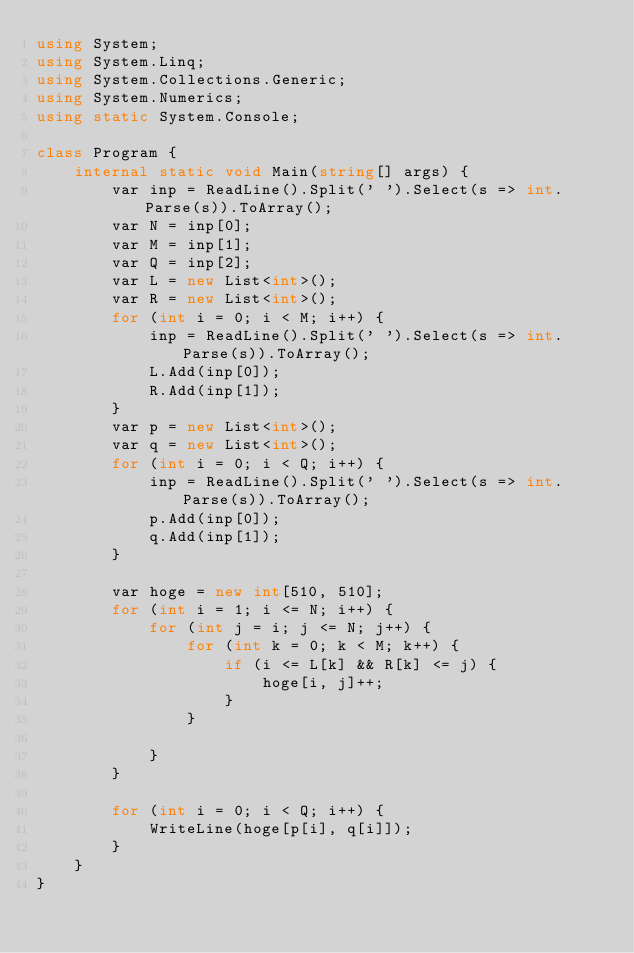Convert code to text. <code><loc_0><loc_0><loc_500><loc_500><_C#_>using System;
using System.Linq;
using System.Collections.Generic;
using System.Numerics;
using static System.Console;

class Program {
    internal static void Main(string[] args) {
        var inp = ReadLine().Split(' ').Select(s => int.Parse(s)).ToArray();
        var N = inp[0];
        var M = inp[1];
        var Q = inp[2];
        var L = new List<int>();
        var R = new List<int>();
        for (int i = 0; i < M; i++) {
            inp = ReadLine().Split(' ').Select(s => int.Parse(s)).ToArray();
            L.Add(inp[0]);
            R.Add(inp[1]);
        }
        var p = new List<int>();
        var q = new List<int>();
        for (int i = 0; i < Q; i++) {
            inp = ReadLine().Split(' ').Select(s => int.Parse(s)).ToArray();
            p.Add(inp[0]);
            q.Add(inp[1]);
        }

        var hoge = new int[510, 510];
        for (int i = 1; i <= N; i++) {
            for (int j = i; j <= N; j++) {
                for (int k = 0; k < M; k++) {
                    if (i <= L[k] && R[k] <= j) {
                        hoge[i, j]++;
                    }
                }

            }
        }

        for (int i = 0; i < Q; i++) {
            WriteLine(hoge[p[i], q[i]]);
        }
    }
}</code> 